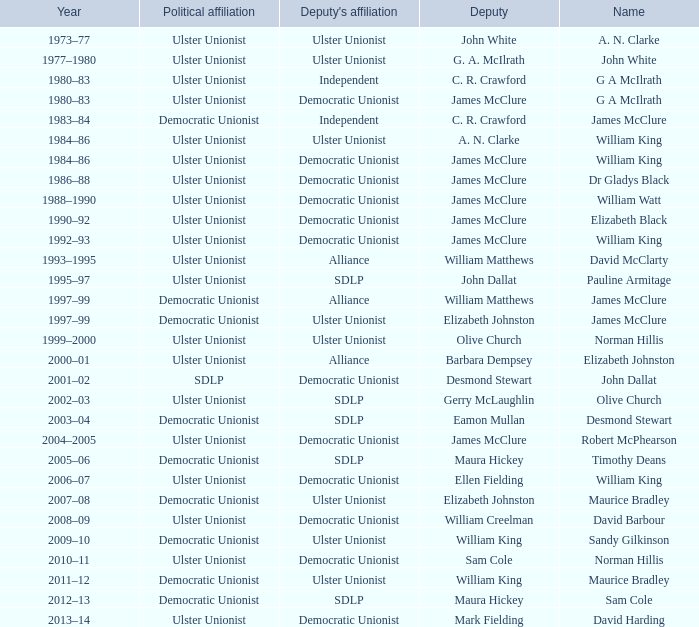What is the Political affiliation of deputy john dallat? Ulster Unionist. 